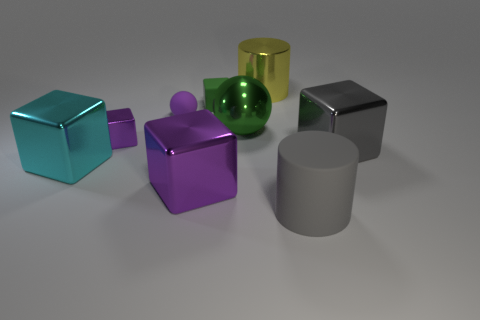What number of green objects are behind the large green ball?
Provide a short and direct response. 1. How big is the shiny cylinder?
Ensure brevity in your answer.  Large. What color is the matte cylinder that is the same size as the metallic cylinder?
Ensure brevity in your answer.  Gray. Is there a metal thing of the same color as the matte cylinder?
Give a very brief answer. Yes. What is the material of the green cube?
Offer a terse response. Rubber. How many cyan objects are there?
Ensure brevity in your answer.  1. There is a large cylinder on the left side of the large gray cylinder; is it the same color as the matte object in front of the big gray cube?
Keep it short and to the point. No. What size is the other shiny block that is the same color as the small metallic block?
Provide a succinct answer. Large. How many other objects are there of the same size as the cyan cube?
Your answer should be compact. 5. The big cylinder behind the large gray metal object is what color?
Your answer should be very brief. Yellow. 